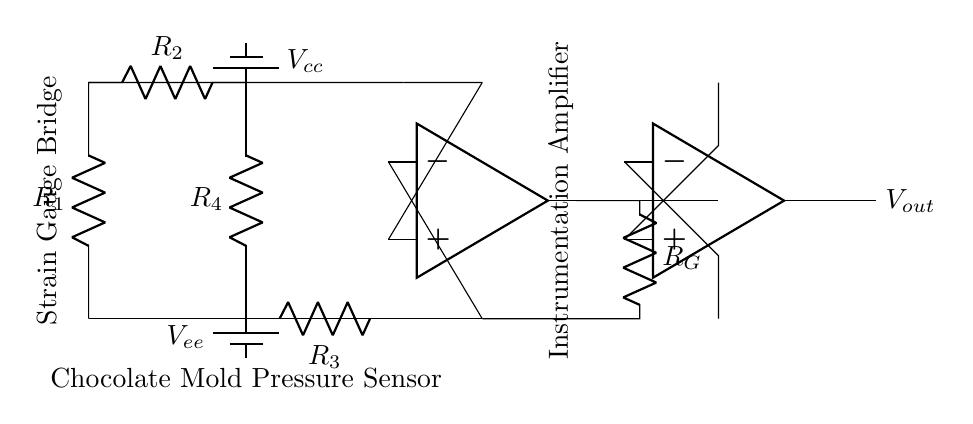What type of sensor is used in this circuit? The circuit features a strain gauge bridge as evidenced by the arrangement of resistors that respond to deformation or strain.
Answer: Strain gauge What does the output signal represent? The output signal, labeled Vout, represents the amplified voltage output corresponding to the pressure sensed by the strain gauge bridge.
Answer: Amplified output voltage How many resistors are in the strain gauge bridge? There are four resistors (R1, R2, R3, R4) in the strain gauge bridge configuration, as shown in the circuit diagram.
Answer: Four Which components form the instrumentation amplifier? The instrumentation amplifier consists of two operational amplifiers (opamp1 and opamp2) that amplify the differential signal from the strain gauge bridge.
Answer: Two operational amplifiers What is the purpose of the resistor labeled Rg? The resistor Rg is used to set the gain of the instrumentation amplifier, affecting how much the input voltage from the strain gauge bridge is amplified to the output.
Answer: Gain setting What is the power supply voltage indicated in the circuit? The circuit shows two power supply voltages; Vcc is the positive supply voltage and Vee is the negative supply voltage connected to the strain gauge bridge and amplifiers.
Answer: Vcc and Vee What type of connection is used between the strain gauge bridge and the instrumentation amplifier? The connection is a voltage input, where the voltage difference from the strain gauge bridge is fed into the non-inverting and inverting inputs of the instrumentation amplifier.
Answer: Voltage input 